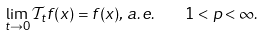<formula> <loc_0><loc_0><loc_500><loc_500>\lim _ { t \rightarrow 0 } { \mathcal { T } } _ { t } f ( x ) = f ( x ) , \, a . e . \quad 1 < p < \infty .</formula> 